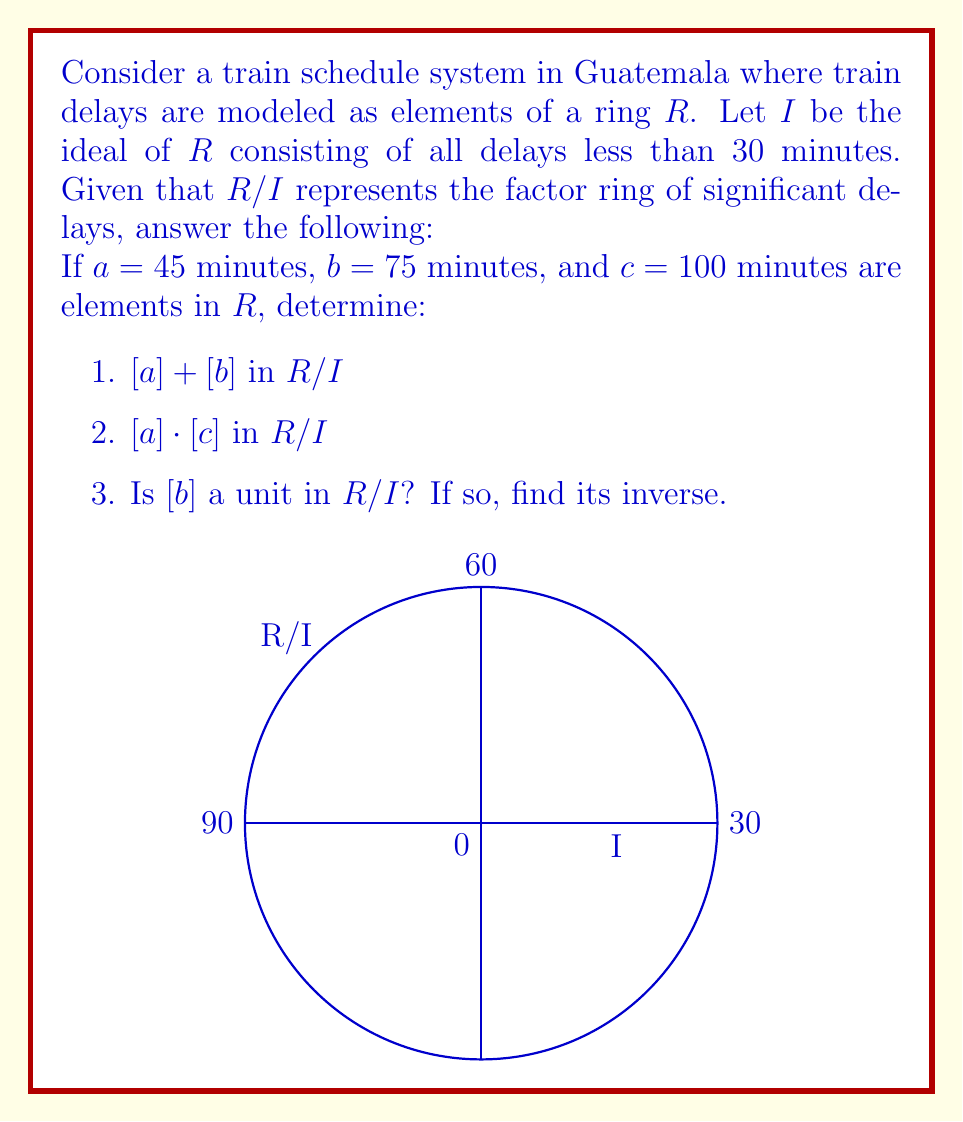Can you answer this question? Let's approach this step-by-step:

1) For $[a] + [b]$ in $R/I$:
   $[a] + [b] = [a + b] = [45 + 75] = [120]$
   Since we're working in $R/I$, we need to consider this modulo delays of 30 minutes.
   $120 \equiv 0 \pmod{30}$
   Therefore, $[a] + [b] = [0]$ in $R/I$

2) For $[a] \cdot [c]$ in $R/I$:
   $[a] \cdot [c] = [a \cdot c] = [45 \cdot 100] = [4500]$
   Again, we need to consider this modulo delays of 30 minutes.
   $4500 \equiv 0 \pmod{30}$
   Therefore, $[a] \cdot [c] = [0]$ in $R/I$

3) To determine if $[b]$ is a unit in $R/I$, we need to find if there exists an $[x]$ such that $[b] \cdot [x] = [1]$ in $R/I$.
   $[b] = [75] \equiv [15] \pmod{30}$ in $R/I$
   We need to find $[x]$ such that $[15] \cdot [x] \equiv [1] \pmod{30}$
   This is equivalent to solving $15x \equiv 1 \pmod{30}$
   The solution is $x \equiv 2 \pmod{30}$
   Therefore, $[b]^{-1} = [2]$ in $R/I$, and $[b]$ is indeed a unit in $R/I$.
Answer: 1) $[0]$
2) $[0]$
3) Yes, $[b]^{-1} = [2]$ 